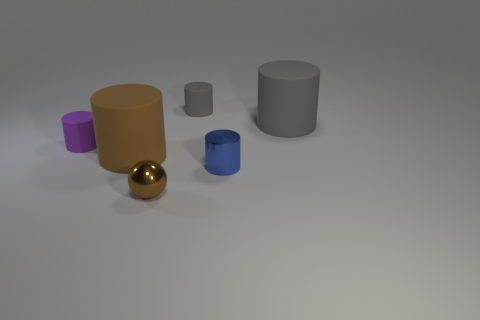The matte thing on the right side of the gray matte thing to the left of the big thing behind the large brown cylinder is what color? The small matte object on the right side of the gray matte object, which is adjacent to the left of the taller gray cylinder and behind the large brown cylinder, is blue in color. 